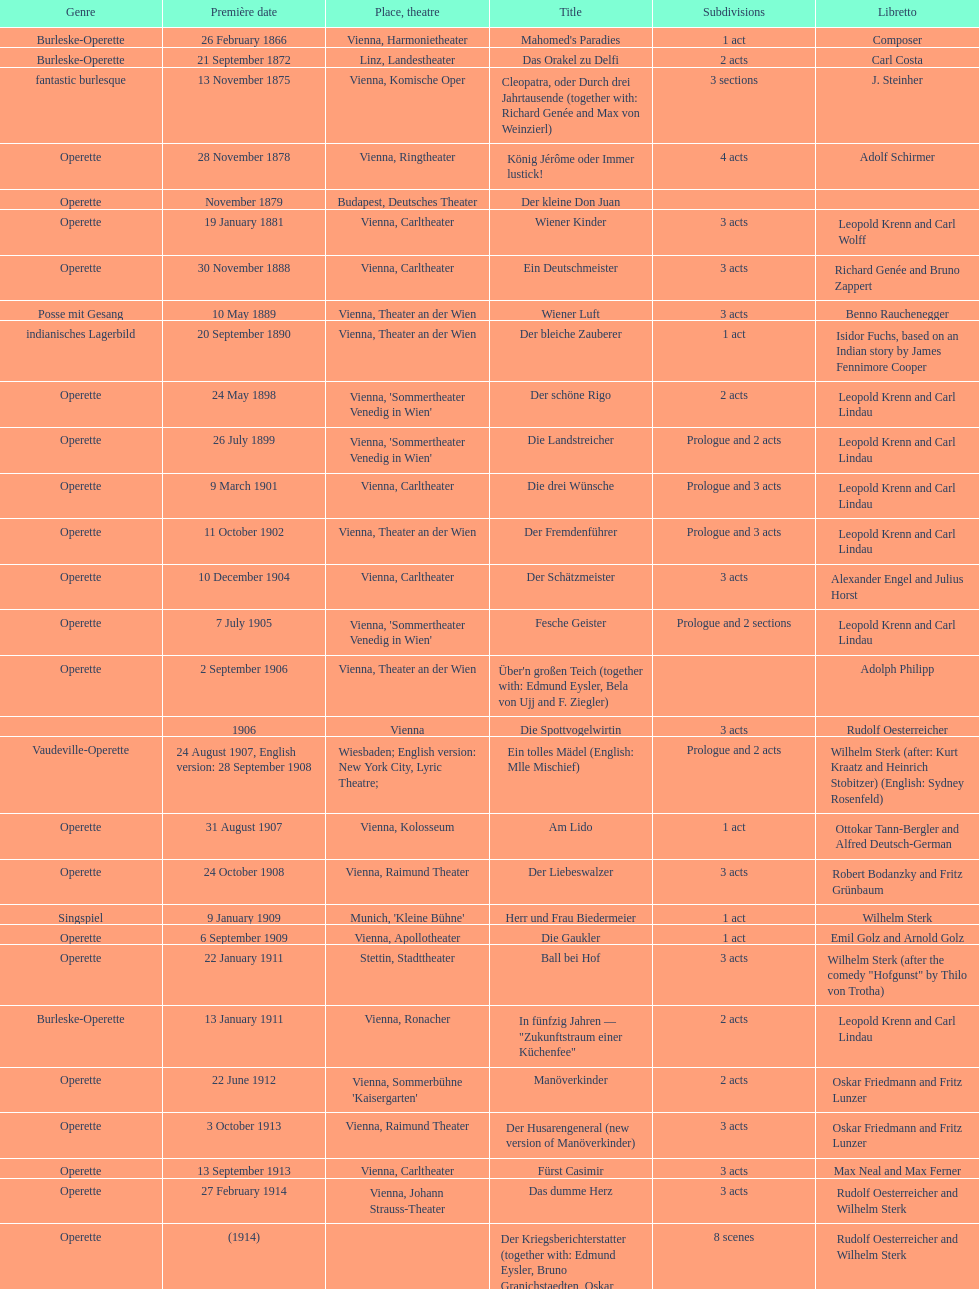Which year did he release his last operetta? 1930. 